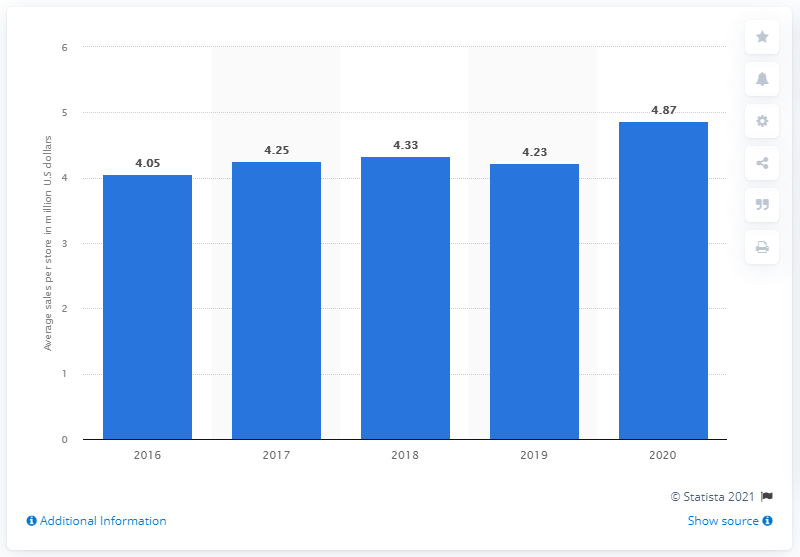Mention a couple of crucial points in this snapshot. In 2020, Ollie's Bargain Outlet Inc. reported an average sales per store of 4.87 in the United States. According to the provided information, the average sales per store for Ollie's Bargain Outlet Inc. was 4.23 per year earlier. 